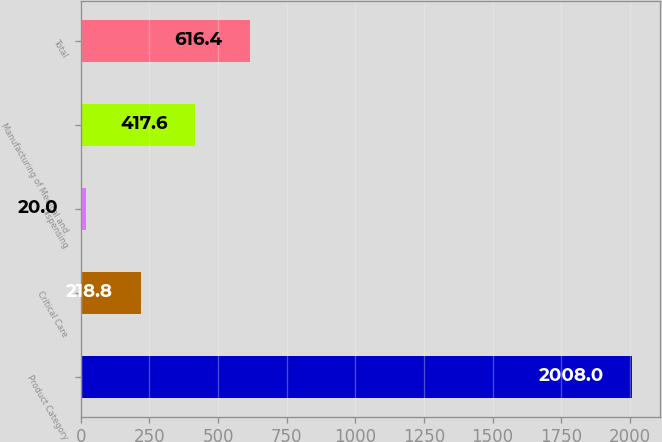<chart> <loc_0><loc_0><loc_500><loc_500><bar_chart><fcel>Product Category<fcel>Critical Care<fcel>Dispensing<fcel>Manufacturing of Medical and<fcel>Total<nl><fcel>2008<fcel>218.8<fcel>20<fcel>417.6<fcel>616.4<nl></chart> 